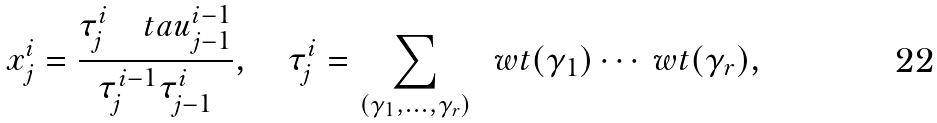<formula> <loc_0><loc_0><loc_500><loc_500>x ^ { i } _ { j } = \frac { \tau ^ { i } _ { j } \quad t a u ^ { i - 1 } _ { j - 1 } } { \tau ^ { i - 1 } _ { j } \tau ^ { i } _ { j - 1 } } , \quad \tau ^ { i } _ { j } = \sum _ { ( \gamma _ { 1 } , \dots , \gamma _ { r } ) } \ \ w t ( \gamma _ { 1 } ) \cdots \ w t ( \gamma _ { r } ) ,</formula> 